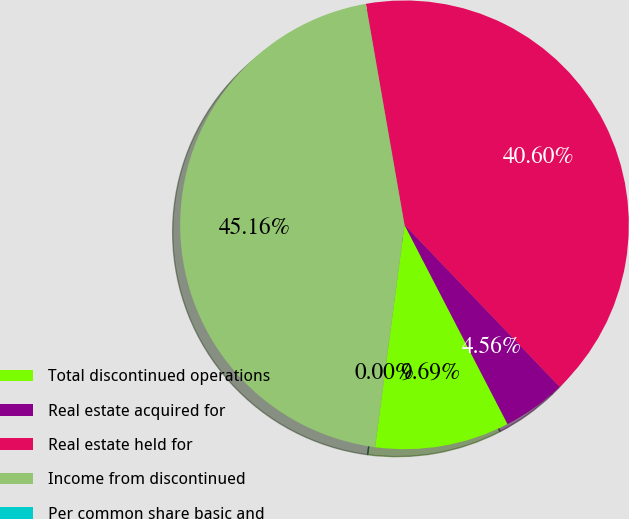Convert chart. <chart><loc_0><loc_0><loc_500><loc_500><pie_chart><fcel>Total discontinued operations<fcel>Real estate acquired for<fcel>Real estate held for<fcel>Income from discontinued<fcel>Per common share basic and<nl><fcel>9.69%<fcel>4.56%<fcel>40.6%<fcel>45.16%<fcel>0.0%<nl></chart> 